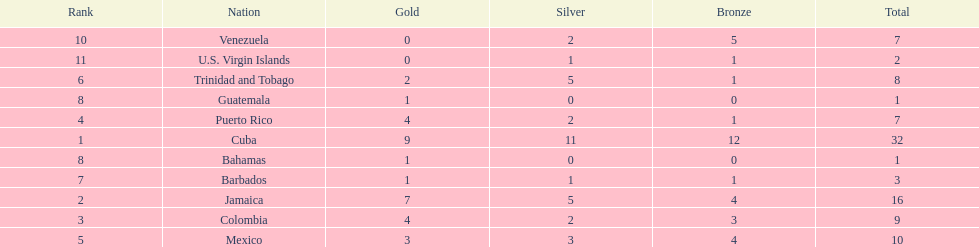Which 3 countries were awarded the most medals? Cuba, Jamaica, Colombia. Of these 3 countries which ones are islands? Cuba, Jamaica. Which one won the most silver medals? Cuba. 